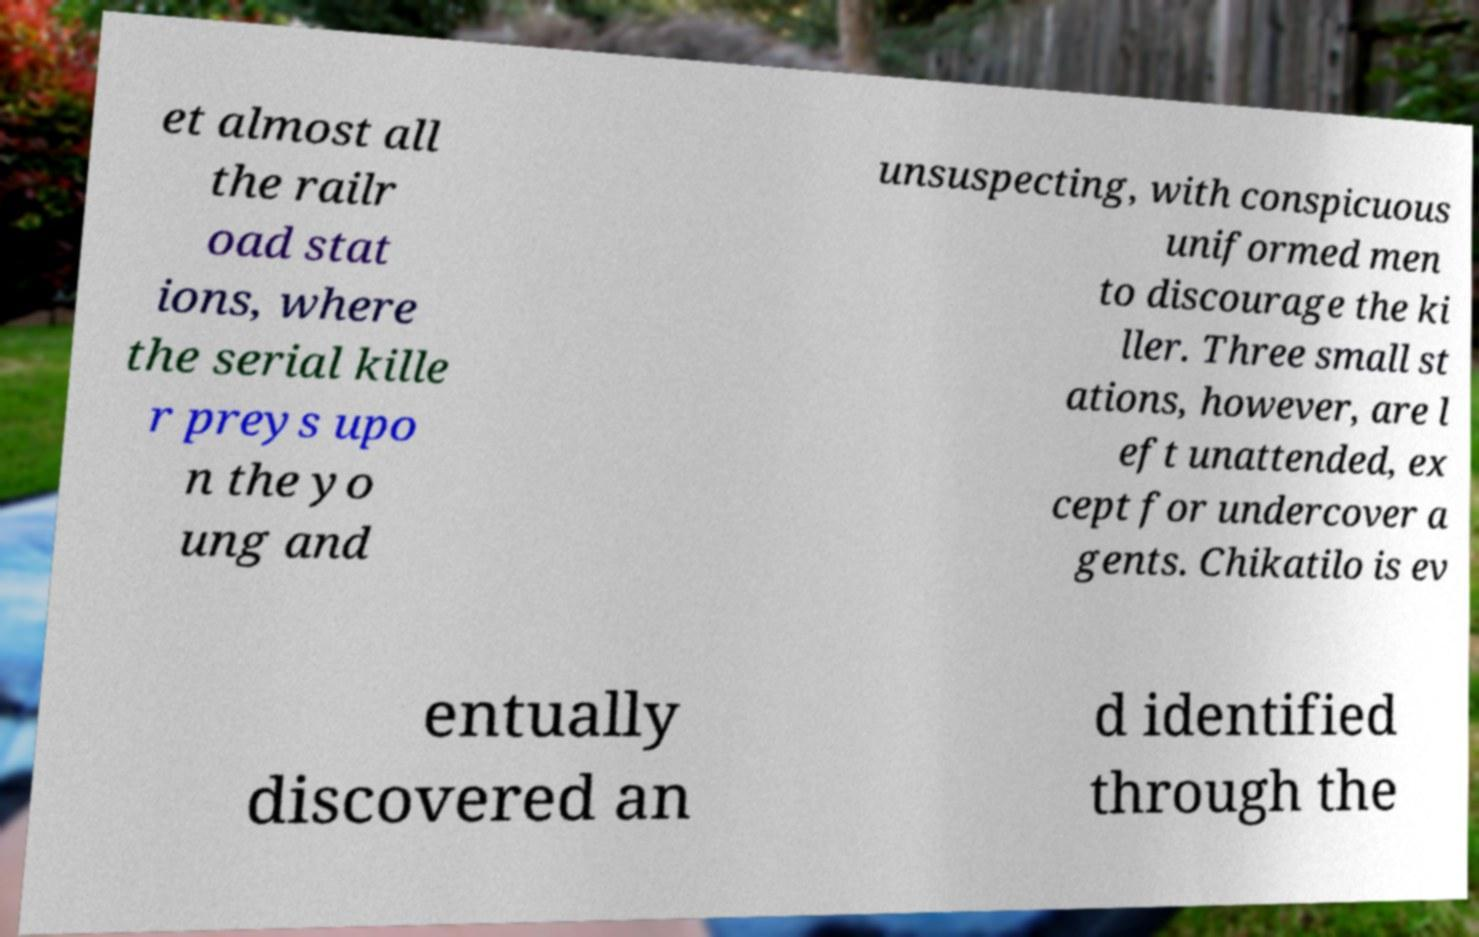For documentation purposes, I need the text within this image transcribed. Could you provide that? et almost all the railr oad stat ions, where the serial kille r preys upo n the yo ung and unsuspecting, with conspicuous uniformed men to discourage the ki ller. Three small st ations, however, are l eft unattended, ex cept for undercover a gents. Chikatilo is ev entually discovered an d identified through the 